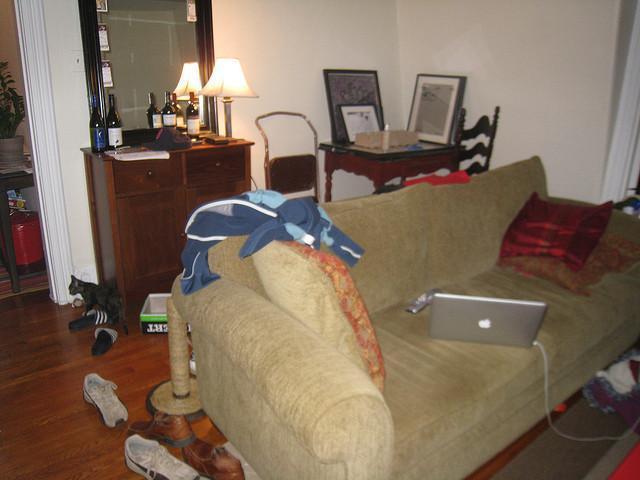How many chairs are there?
Give a very brief answer. 1. 